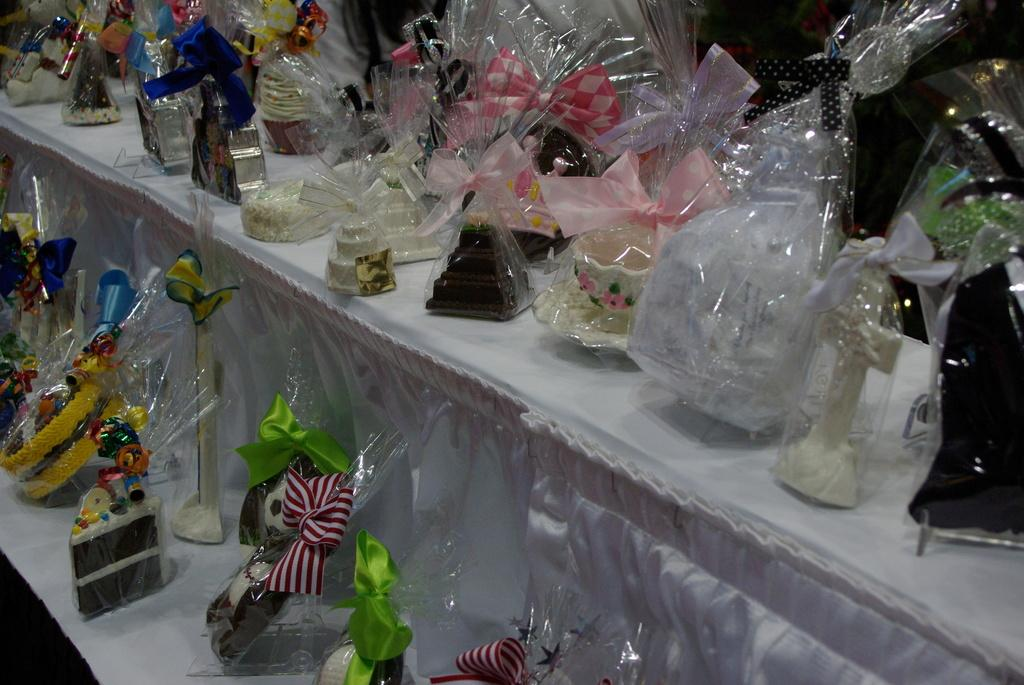What can be seen in the image related to collectibles or decorative items? There are different types of figurines in the image. How are the figurines arranged or stored? The figurines are packed and placed on a stand. What type of toothbrush is used to clean the figurines in the image? There is no toothbrush present in the image, and toothbrushes are not used to clean figurines. 